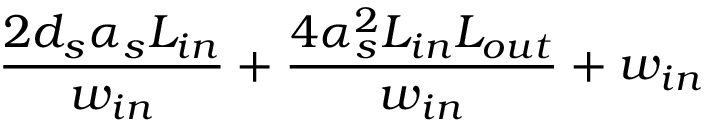<formula> <loc_0><loc_0><loc_500><loc_500>\frac { 2 d _ { s } \alpha _ { s } L _ { i n } } { w _ { i n } } + \frac { 4 \alpha _ { s } ^ { 2 } L _ { i n } L _ { o u t } } { w _ { i n } } + w _ { i n }</formula> 